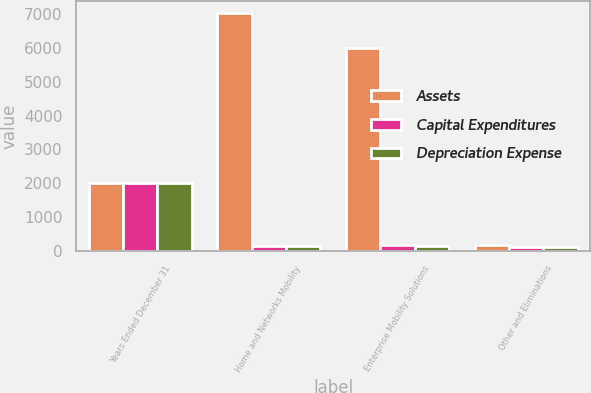Convert chart. <chart><loc_0><loc_0><loc_500><loc_500><stacked_bar_chart><ecel><fcel>Years Ended December 31<fcel>Home and Networks Mobility<fcel>Enterprise Mobility Solutions<fcel>Other and Eliminations<nl><fcel>Assets<fcel>2008<fcel>7024<fcel>6000<fcel>166<nl><fcel>Capital Expenditures<fcel>2008<fcel>147<fcel>166<fcel>107<nl><fcel>Depreciation Expense<fcel>2008<fcel>135<fcel>158<fcel>103<nl></chart> 